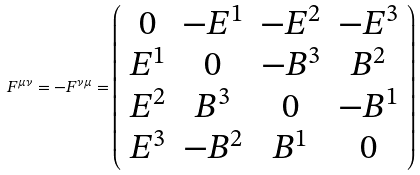<formula> <loc_0><loc_0><loc_500><loc_500>F ^ { \mu \nu } = - F ^ { \nu \mu } = \left ( \begin{array} { c c c c } 0 & - E ^ { 1 } & - E ^ { 2 } & - E ^ { 3 } \\ E ^ { 1 } & 0 & - B ^ { 3 } & B ^ { 2 } \\ E ^ { 2 } & B ^ { 3 } & 0 & - B ^ { 1 } \\ E ^ { 3 } & - B ^ { 2 } & B ^ { 1 } & 0 \end{array} \right ) \,</formula> 